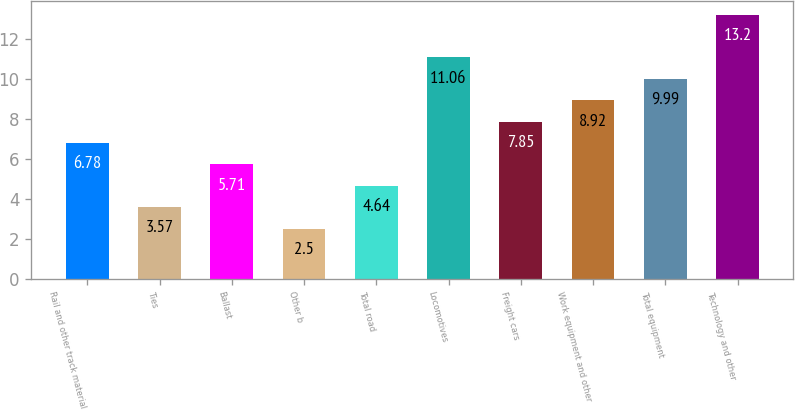Convert chart to OTSL. <chart><loc_0><loc_0><loc_500><loc_500><bar_chart><fcel>Rail and other track material<fcel>Ties<fcel>Ballast<fcel>Other b<fcel>Total road<fcel>Locomotives<fcel>Freight cars<fcel>Work equipment and other<fcel>Total equipment<fcel>Technology and other<nl><fcel>6.78<fcel>3.57<fcel>5.71<fcel>2.5<fcel>4.64<fcel>11.06<fcel>7.85<fcel>8.92<fcel>9.99<fcel>13.2<nl></chart> 